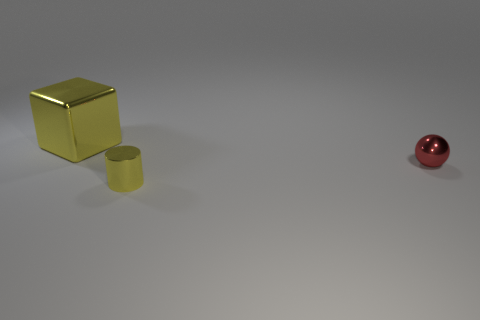Subtract all green spheres. Subtract all purple cylinders. How many spheres are left? 1 Add 1 tiny red shiny spheres. How many objects exist? 4 Subtract all blocks. How many objects are left? 2 Add 1 large metallic cubes. How many large metallic cubes are left? 2 Add 3 big yellow blocks. How many big yellow blocks exist? 4 Subtract 0 gray spheres. How many objects are left? 3 Subtract all small cylinders. Subtract all metallic blocks. How many objects are left? 1 